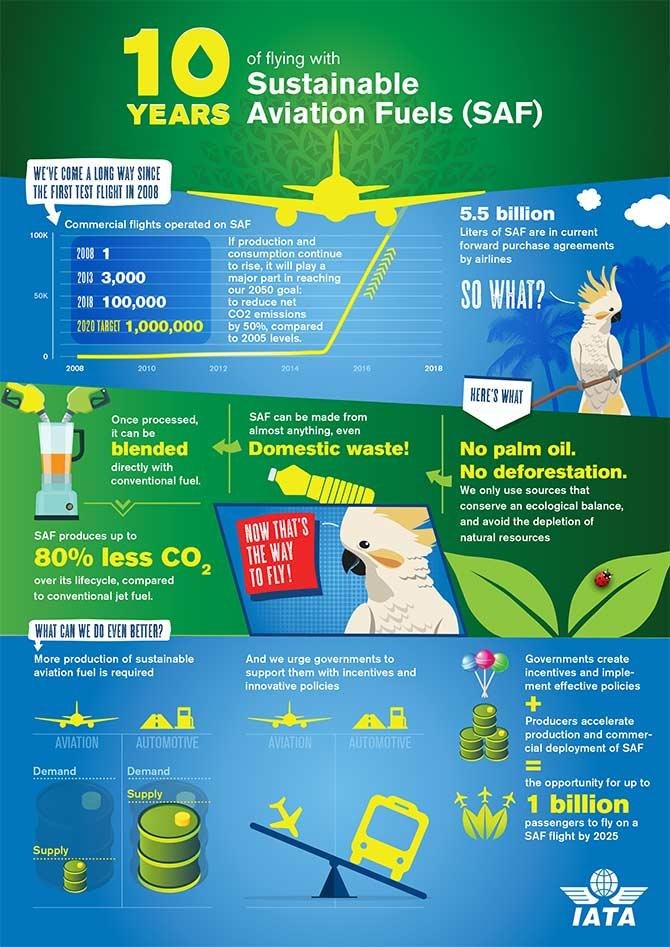Give some essential details in this illustration. There were a total of 10,300 flights in 2013 and 2018 combined. 